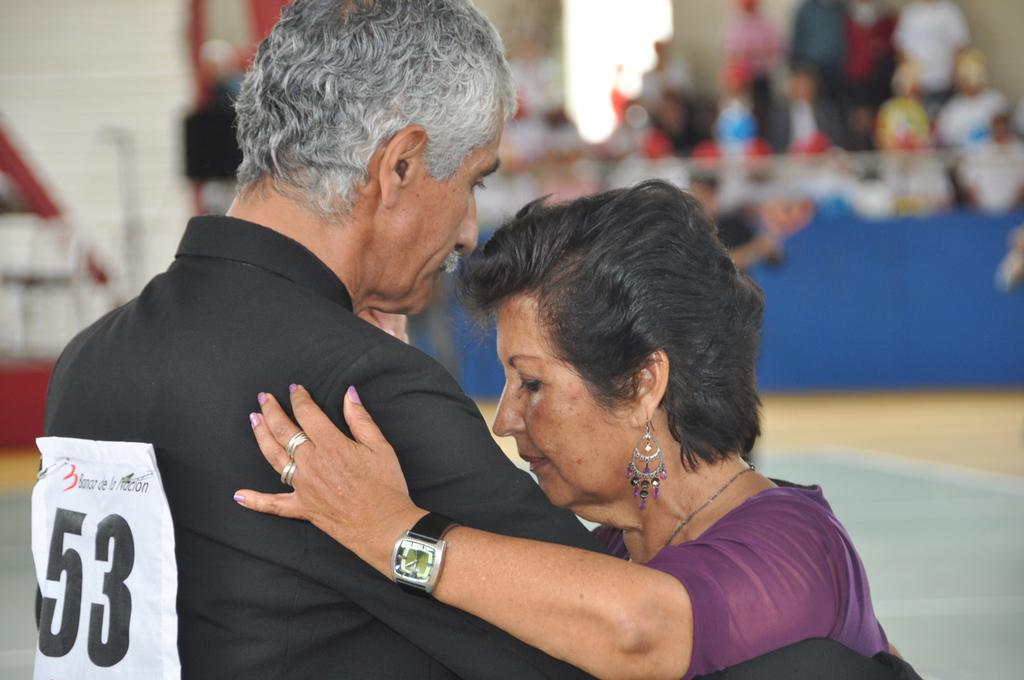<image>
Render a clear and concise summary of the photo. A man with number 53 pinned to his back dances with a woman in a competition. 